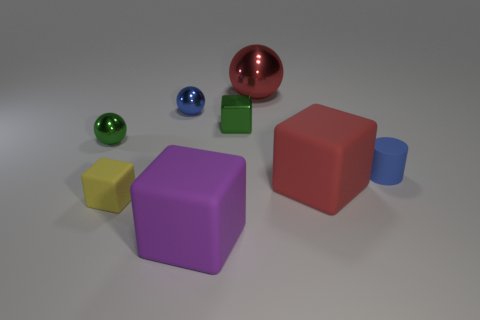Add 1 large objects. How many objects exist? 9 Subtract all spheres. How many objects are left? 5 Subtract 1 red spheres. How many objects are left? 7 Subtract all rubber blocks. Subtract all large red matte blocks. How many objects are left? 4 Add 4 blue balls. How many blue balls are left? 5 Add 3 big cyan shiny cylinders. How many big cyan shiny cylinders exist? 3 